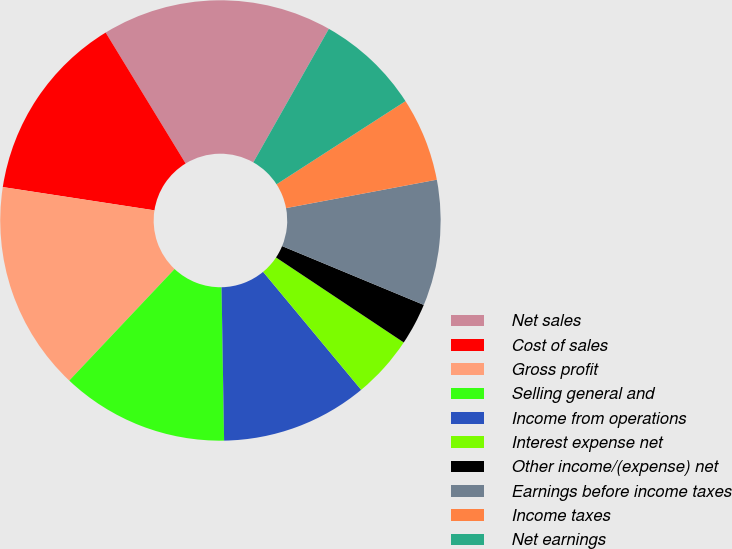Convert chart. <chart><loc_0><loc_0><loc_500><loc_500><pie_chart><fcel>Net sales<fcel>Cost of sales<fcel>Gross profit<fcel>Selling general and<fcel>Income from operations<fcel>Interest expense net<fcel>Other income/(expense) net<fcel>Earnings before income taxes<fcel>Income taxes<fcel>Net earnings<nl><fcel>16.92%<fcel>13.85%<fcel>15.38%<fcel>12.31%<fcel>10.77%<fcel>4.62%<fcel>3.08%<fcel>9.23%<fcel>6.15%<fcel>7.69%<nl></chart> 